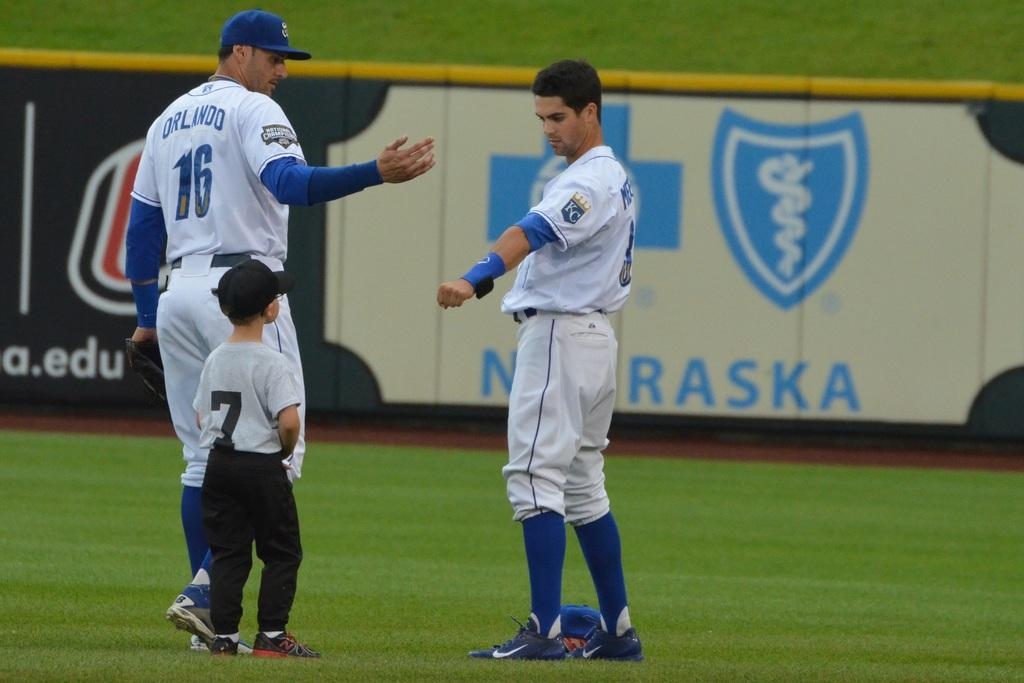<image>
Share a concise interpretation of the image provided. a baseball player on the field with the word Nebraska in the background 